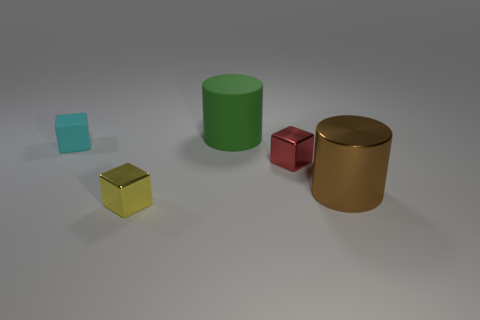Add 1 yellow metallic cylinders. How many objects exist? 6 Subtract all cylinders. How many objects are left? 3 Add 4 small blocks. How many small blocks are left? 7 Add 5 big brown metal cubes. How many big brown metal cubes exist? 5 Subtract 0 brown spheres. How many objects are left? 5 Subtract all small brown cylinders. Subtract all big green rubber objects. How many objects are left? 4 